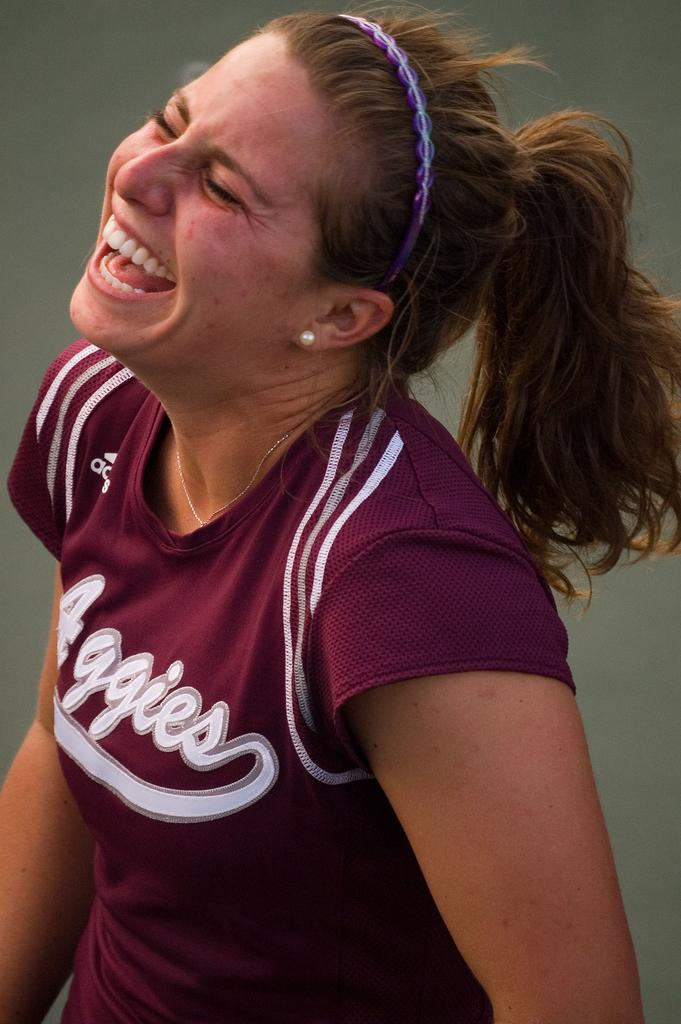<image>
Create a compact narrative representing the image presented. Girl wearing a purple shirt which says Aggies on it. 